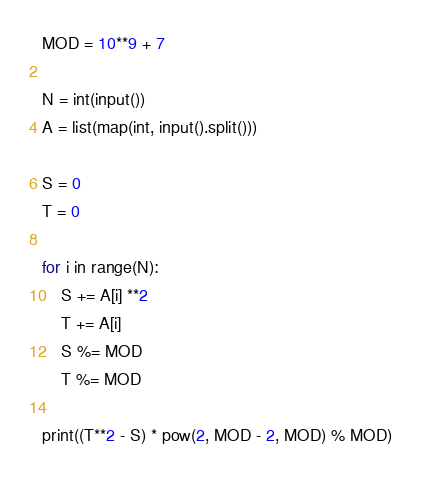Convert code to text. <code><loc_0><loc_0><loc_500><loc_500><_Python_>MOD = 10**9 + 7

N = int(input())
A = list(map(int, input().split()))

S = 0
T = 0

for i in range(N):
    S += A[i] **2
    T += A[i]
    S %= MOD
    T %= MOD

print((T**2 - S) * pow(2, MOD - 2, MOD) % MOD)</code> 